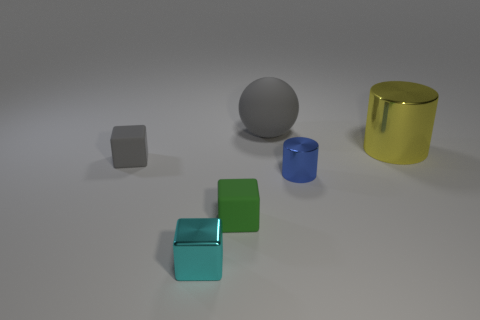Add 3 large yellow metal cylinders. How many objects exist? 9 Subtract all spheres. How many objects are left? 5 Subtract all small shiny cubes. Subtract all metal objects. How many objects are left? 2 Add 1 green objects. How many green objects are left? 2 Add 4 small yellow blocks. How many small yellow blocks exist? 4 Subtract 0 green spheres. How many objects are left? 6 